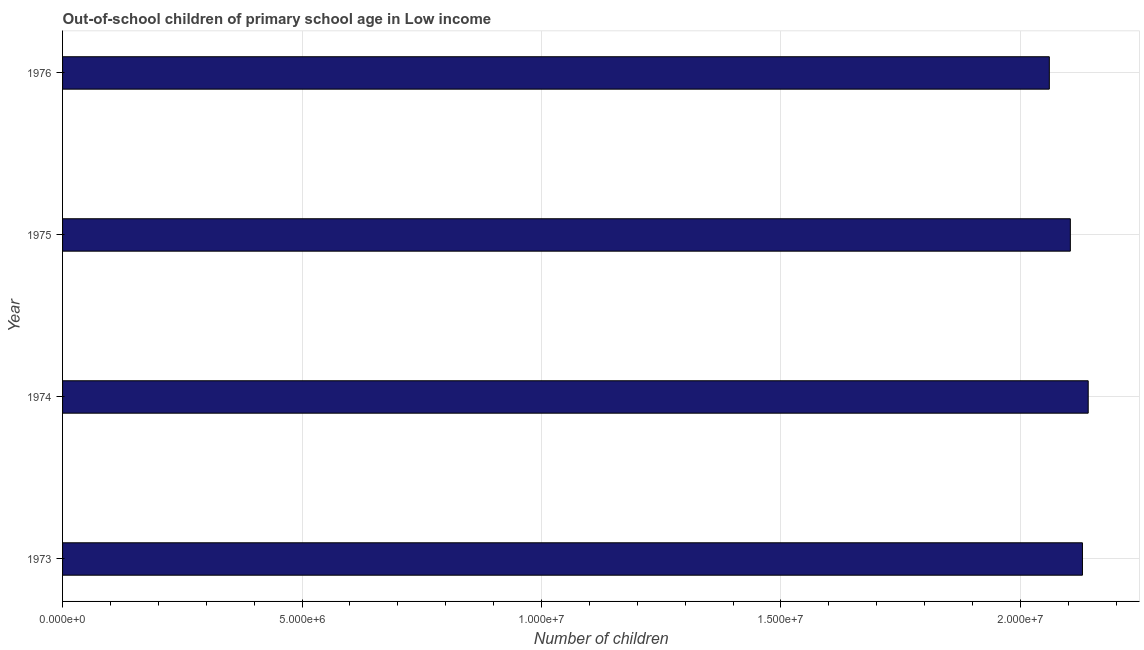What is the title of the graph?
Ensure brevity in your answer.  Out-of-school children of primary school age in Low income. What is the label or title of the X-axis?
Ensure brevity in your answer.  Number of children. What is the number of out-of-school children in 1976?
Ensure brevity in your answer.  2.06e+07. Across all years, what is the maximum number of out-of-school children?
Provide a short and direct response. 2.14e+07. Across all years, what is the minimum number of out-of-school children?
Provide a short and direct response. 2.06e+07. In which year was the number of out-of-school children maximum?
Provide a succinct answer. 1974. In which year was the number of out-of-school children minimum?
Keep it short and to the point. 1976. What is the sum of the number of out-of-school children?
Provide a succinct answer. 8.44e+07. What is the difference between the number of out-of-school children in 1973 and 1974?
Provide a succinct answer. -1.20e+05. What is the average number of out-of-school children per year?
Give a very brief answer. 2.11e+07. What is the median number of out-of-school children?
Provide a succinct answer. 2.12e+07. What is the difference between the highest and the second highest number of out-of-school children?
Provide a short and direct response. 1.20e+05. What is the difference between the highest and the lowest number of out-of-school children?
Give a very brief answer. 8.12e+05. How many years are there in the graph?
Offer a very short reply. 4. What is the Number of children of 1973?
Ensure brevity in your answer.  2.13e+07. What is the Number of children in 1974?
Provide a short and direct response. 2.14e+07. What is the Number of children in 1975?
Ensure brevity in your answer.  2.10e+07. What is the Number of children of 1976?
Provide a succinct answer. 2.06e+07. What is the difference between the Number of children in 1973 and 1974?
Offer a very short reply. -1.20e+05. What is the difference between the Number of children in 1973 and 1975?
Make the answer very short. 2.53e+05. What is the difference between the Number of children in 1973 and 1976?
Provide a short and direct response. 6.92e+05. What is the difference between the Number of children in 1974 and 1975?
Your answer should be very brief. 3.73e+05. What is the difference between the Number of children in 1974 and 1976?
Offer a very short reply. 8.12e+05. What is the difference between the Number of children in 1975 and 1976?
Make the answer very short. 4.39e+05. What is the ratio of the Number of children in 1973 to that in 1976?
Your answer should be very brief. 1.03. What is the ratio of the Number of children in 1974 to that in 1976?
Make the answer very short. 1.04. What is the ratio of the Number of children in 1975 to that in 1976?
Give a very brief answer. 1.02. 